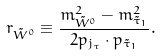<formula> <loc_0><loc_0><loc_500><loc_500>r _ { \tilde { W } ^ { 0 } } \equiv \frac { m _ { \tilde { W } ^ { 0 } } ^ { 2 } - m _ { \tilde { \tau } _ { 1 } } ^ { 2 } } { 2 p _ { j _ { \tau } } \cdot p _ { \tilde { \tau } _ { 1 } } } .</formula> 